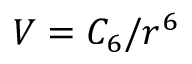<formula> <loc_0><loc_0><loc_500><loc_500>V = C _ { 6 } / r ^ { 6 }</formula> 